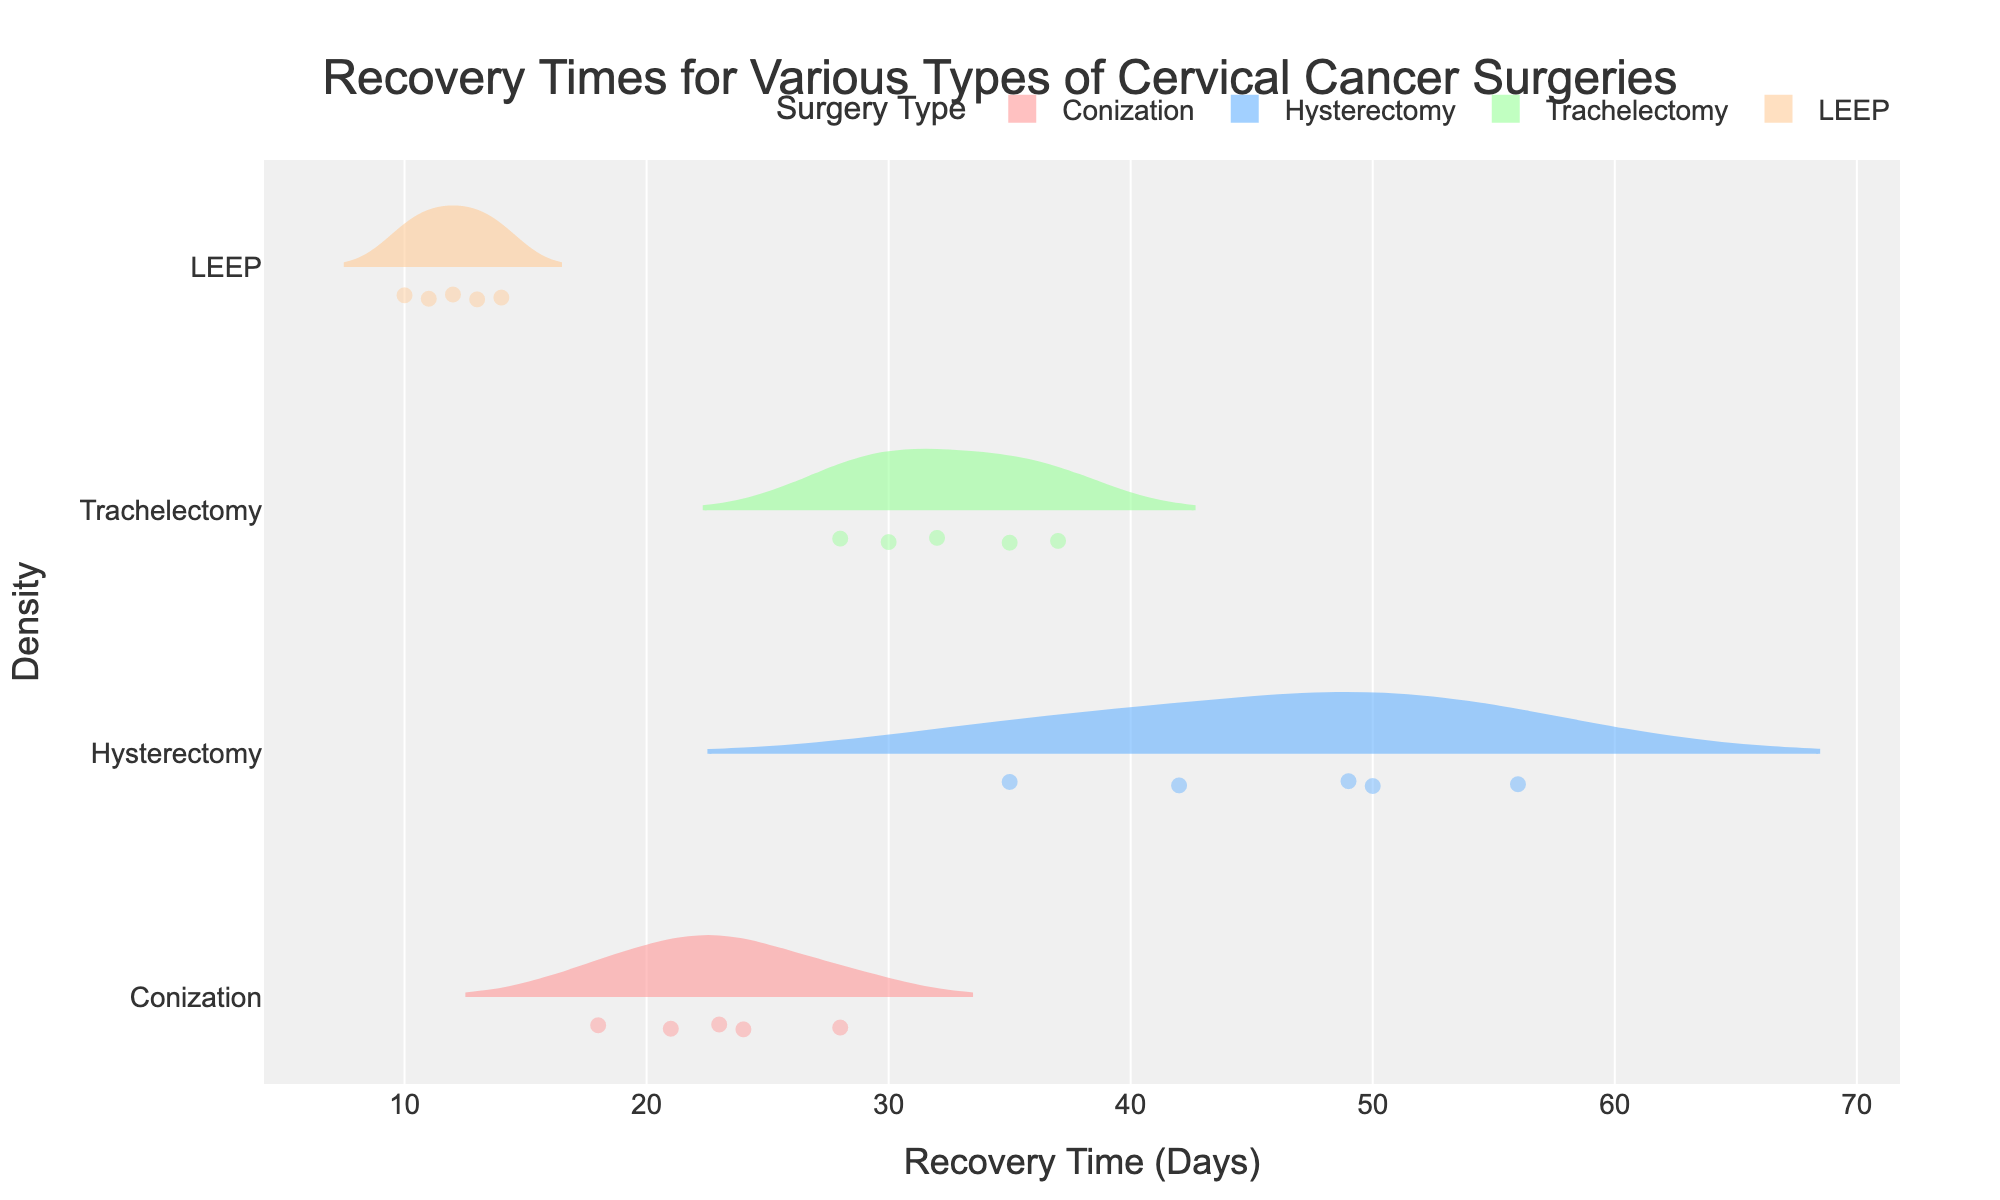What is the title of the figure? The title is generally placed at the top of the figure and is more prominently displayed in larger and bold font. It provides an immediate understanding of what the plot represents.
Answer: Recovery Times for Various Types of Cervical Cancer Surgeries How many surgery types are compared in this figure? The figure compares different types of surgeries, each represented by a distinct color and name in the legend. Counting the items in the legend provides the answer.
Answer: Four Which surgery type has the shortest average recovery time? Examining the meanline for each surgery type shows their average recovery times. The surgery type with the lowest meanline represents the shortest average recovery time.
Answer: LEEP What is the range of recovery times for hysterectomies? Observing the spread of data points for the hysterectomy in the plot shows the minimum and maximum values, indicating the range. The jitter adjusted density points display these values.
Answer: 35 to 56 days Which surgery type shows the most variability in recovery times? The surgery type with the widest spread of data points (farthest points from the mean) represents the highest variability.
Answer: Hysterectomy What is the difference in average recovery times between conization and trachelectomy? Identifying the meanline for each surgery type, we note their average values and subtract the smaller mean from the larger mean to find the difference.
Answer: 7 days Which surgery type has the least dense recovery time distribution? The surgery with the flattest (least peaked) density curve indicates the least dense distribution visually.
Answer: Hysterectomy Comparing LEEP and Trachelectomy, which has more compact recovery times? By observing the spread of data points for each surgery type, LEEP shows a narrower and clustered grouping, indicating more compact recovery times.
Answer: LEEP What is the average recovery time for conization? The meanline in the violin plot for conization shows the average recovery time directly.
Answer: 22.8 days 